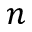<formula> <loc_0><loc_0><loc_500><loc_500>n</formula> 